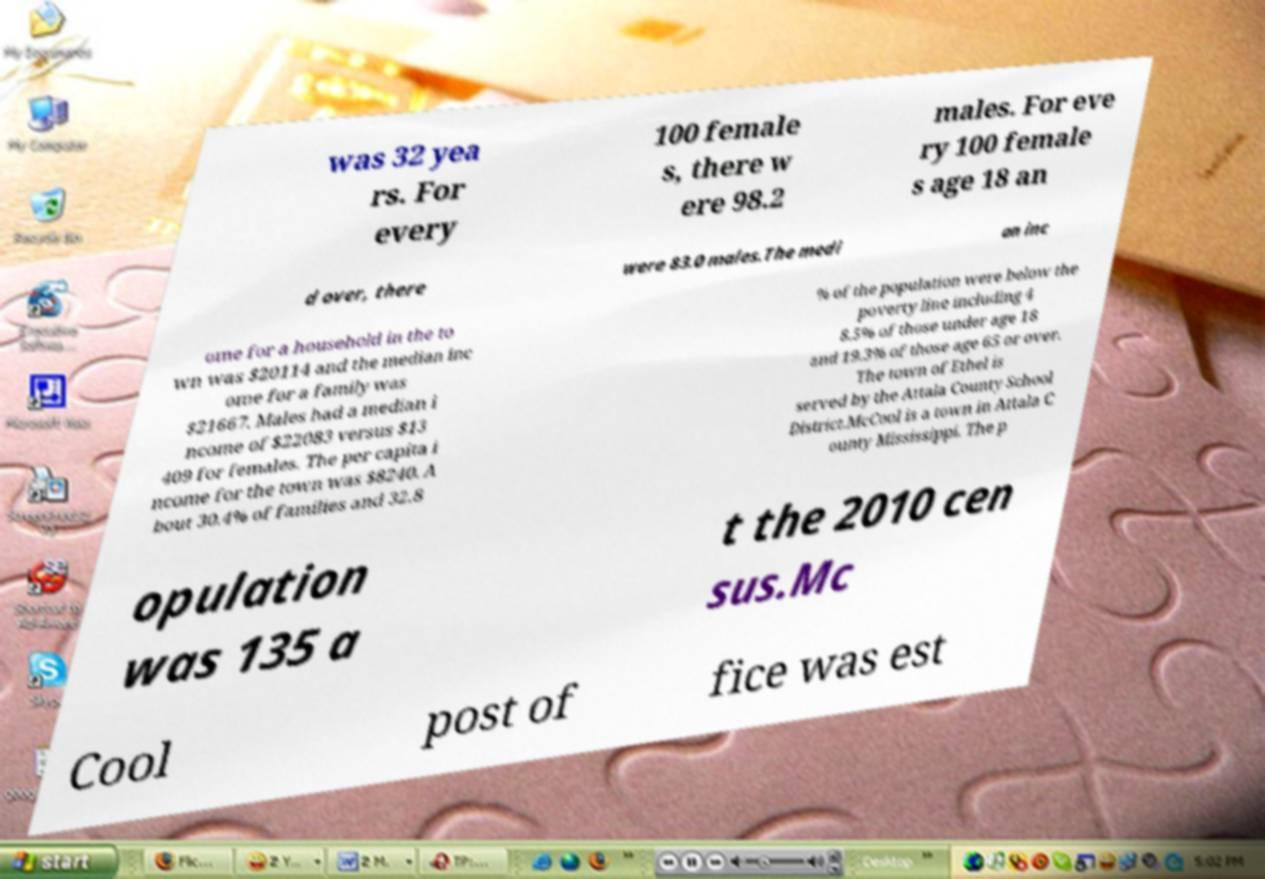Please identify and transcribe the text found in this image. was 32 yea rs. For every 100 female s, there w ere 98.2 males. For eve ry 100 female s age 18 an d over, there were 83.0 males.The medi an inc ome for a household in the to wn was $20114 and the median inc ome for a family was $21667. Males had a median i ncome of $22083 versus $13 409 for females. The per capita i ncome for the town was $8240. A bout 30.4% of families and 32.8 % of the population were below the poverty line including 4 8.5% of those under age 18 and 19.3% of those age 65 or over. The town of Ethel is served by the Attala County School District.McCool is a town in Attala C ounty Mississippi. The p opulation was 135 a t the 2010 cen sus.Mc Cool post of fice was est 